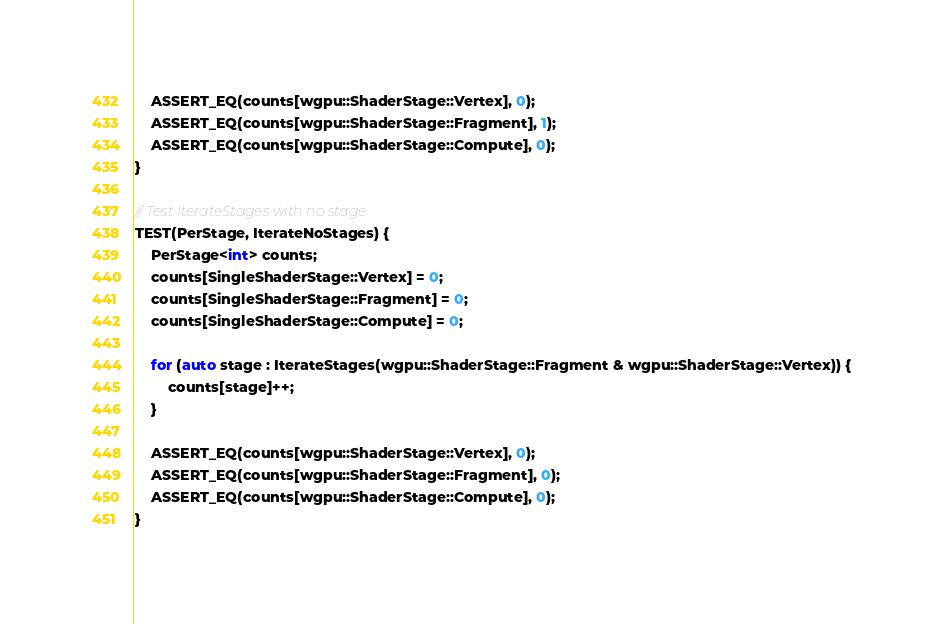<code> <loc_0><loc_0><loc_500><loc_500><_C++_>
    ASSERT_EQ(counts[wgpu::ShaderStage::Vertex], 0);
    ASSERT_EQ(counts[wgpu::ShaderStage::Fragment], 1);
    ASSERT_EQ(counts[wgpu::ShaderStage::Compute], 0);
}

// Test IterateStages with no stage
TEST(PerStage, IterateNoStages) {
    PerStage<int> counts;
    counts[SingleShaderStage::Vertex] = 0;
    counts[SingleShaderStage::Fragment] = 0;
    counts[SingleShaderStage::Compute] = 0;

    for (auto stage : IterateStages(wgpu::ShaderStage::Fragment & wgpu::ShaderStage::Vertex)) {
        counts[stage]++;
    }

    ASSERT_EQ(counts[wgpu::ShaderStage::Vertex], 0);
    ASSERT_EQ(counts[wgpu::ShaderStage::Fragment], 0);
    ASSERT_EQ(counts[wgpu::ShaderStage::Compute], 0);
}
</code> 